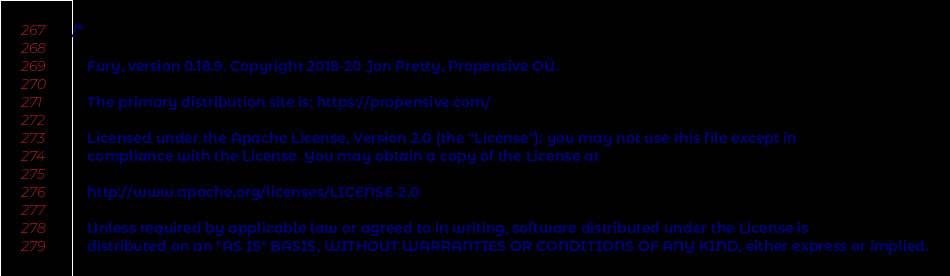<code> <loc_0><loc_0><loc_500><loc_500><_Scala_>/*

    Fury, version 0.18.9. Copyright 2018-20 Jon Pretty, Propensive OÜ.

    The primary distribution site is: https://propensive.com/

    Licensed under the Apache License, Version 2.0 (the "License"); you may not use this file except in
    compliance with the License. You may obtain a copy of the License at

    http://www.apache.org/licenses/LICENSE-2.0

    Unless required by applicable law or agreed to in writing, software distributed under the License is
    distributed on an "AS IS" BASIS, WITHOUT WARRANTIES OR CONDITIONS OF ANY KIND, either express or implied.</code> 